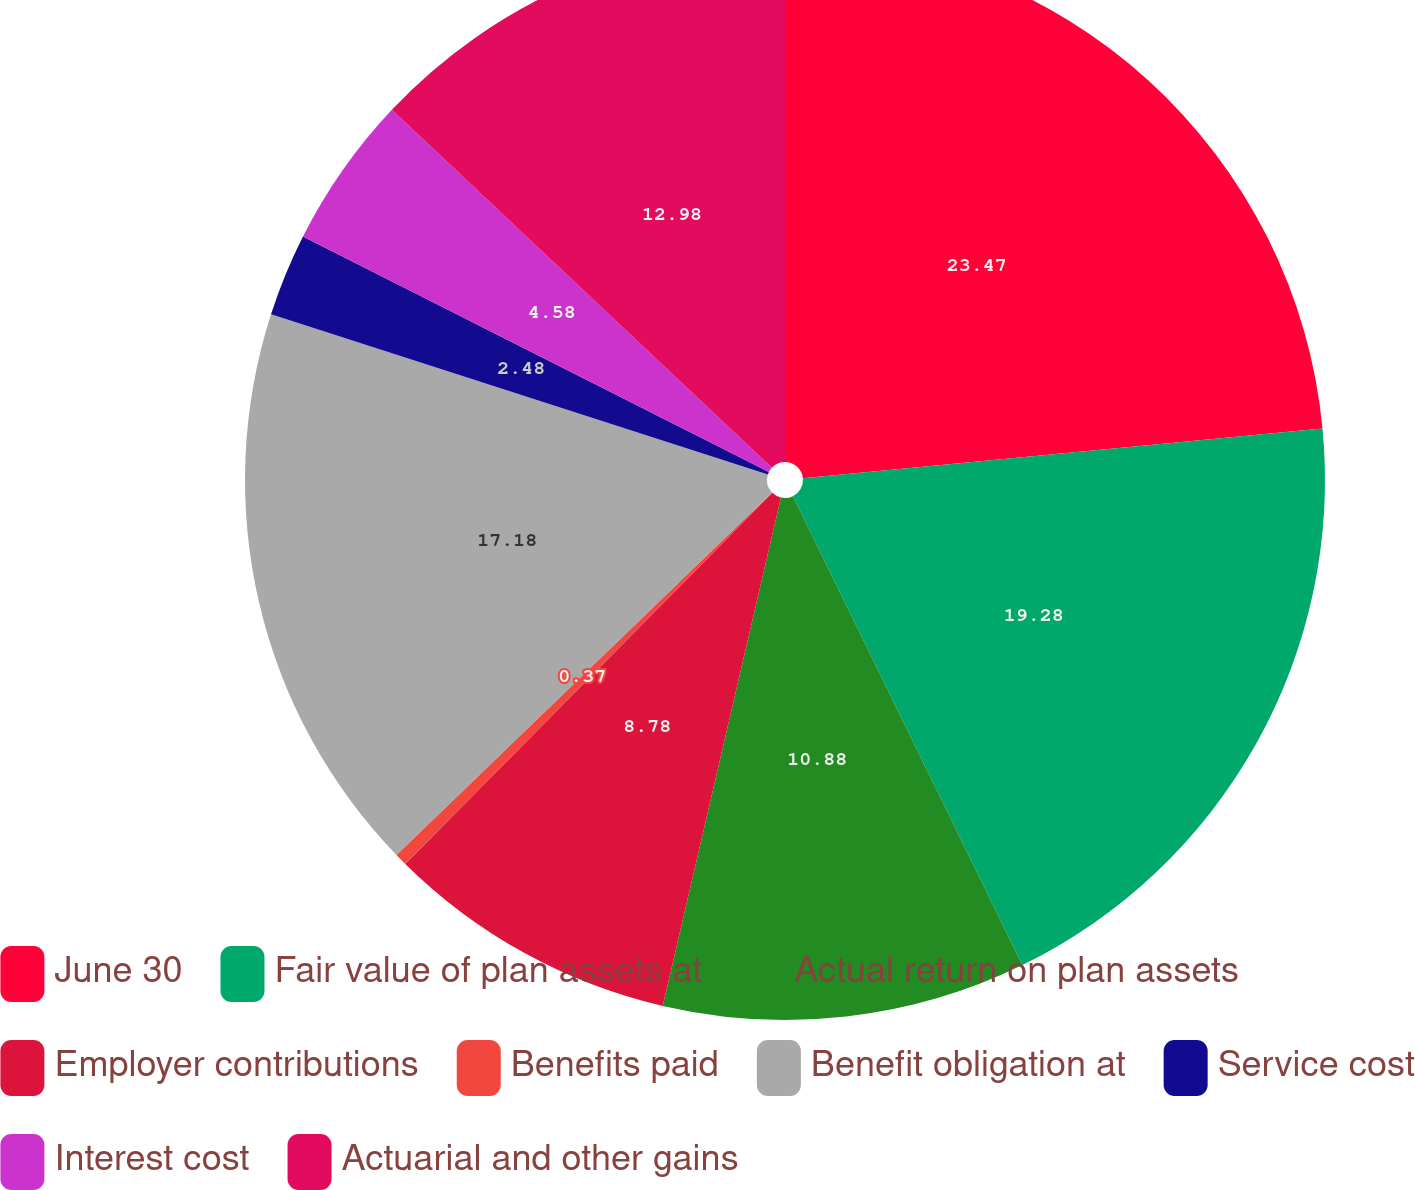Convert chart. <chart><loc_0><loc_0><loc_500><loc_500><pie_chart><fcel>June 30<fcel>Fair value of plan assets at<fcel>Actual return on plan assets<fcel>Employer contributions<fcel>Benefits paid<fcel>Benefit obligation at<fcel>Service cost<fcel>Interest cost<fcel>Actuarial and other gains<nl><fcel>23.48%<fcel>19.28%<fcel>10.88%<fcel>8.78%<fcel>0.37%<fcel>17.18%<fcel>2.48%<fcel>4.58%<fcel>12.98%<nl></chart> 